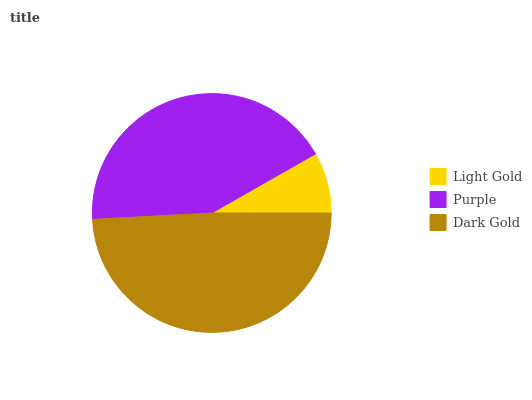Is Light Gold the minimum?
Answer yes or no. Yes. Is Dark Gold the maximum?
Answer yes or no. Yes. Is Purple the minimum?
Answer yes or no. No. Is Purple the maximum?
Answer yes or no. No. Is Purple greater than Light Gold?
Answer yes or no. Yes. Is Light Gold less than Purple?
Answer yes or no. Yes. Is Light Gold greater than Purple?
Answer yes or no. No. Is Purple less than Light Gold?
Answer yes or no. No. Is Purple the high median?
Answer yes or no. Yes. Is Purple the low median?
Answer yes or no. Yes. Is Dark Gold the high median?
Answer yes or no. No. Is Light Gold the low median?
Answer yes or no. No. 